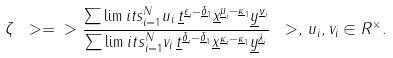Convert formula to latex. <formula><loc_0><loc_0><loc_500><loc_500>\zeta \ > = \ > \frac { \sum \lim i t s _ { i = 1 } ^ { N } u _ { i } \, \underline { t } ^ { \underline { \epsilon } _ { i } - \underline { \delta } _ { 1 } } \underline { x } ^ { \underline { \mu } _ { i } - \underline { \kappa } _ { 1 } } \underline { y } ^ { \underline { \nu } _ { i } } } { \sum \lim i t s _ { i = 1 } ^ { N } v _ { i } \, \underline { t } ^ { \underline { \delta } _ { i } - \underline { \delta } _ { 1 } } \underline { x } ^ { \underline { \kappa } _ { i } - \underline { \kappa } _ { 1 } } \underline { y } ^ { \underline { \lambda } _ { i } } } \ > , \, u _ { i } , v _ { i } \in R ^ { \times } .</formula> 